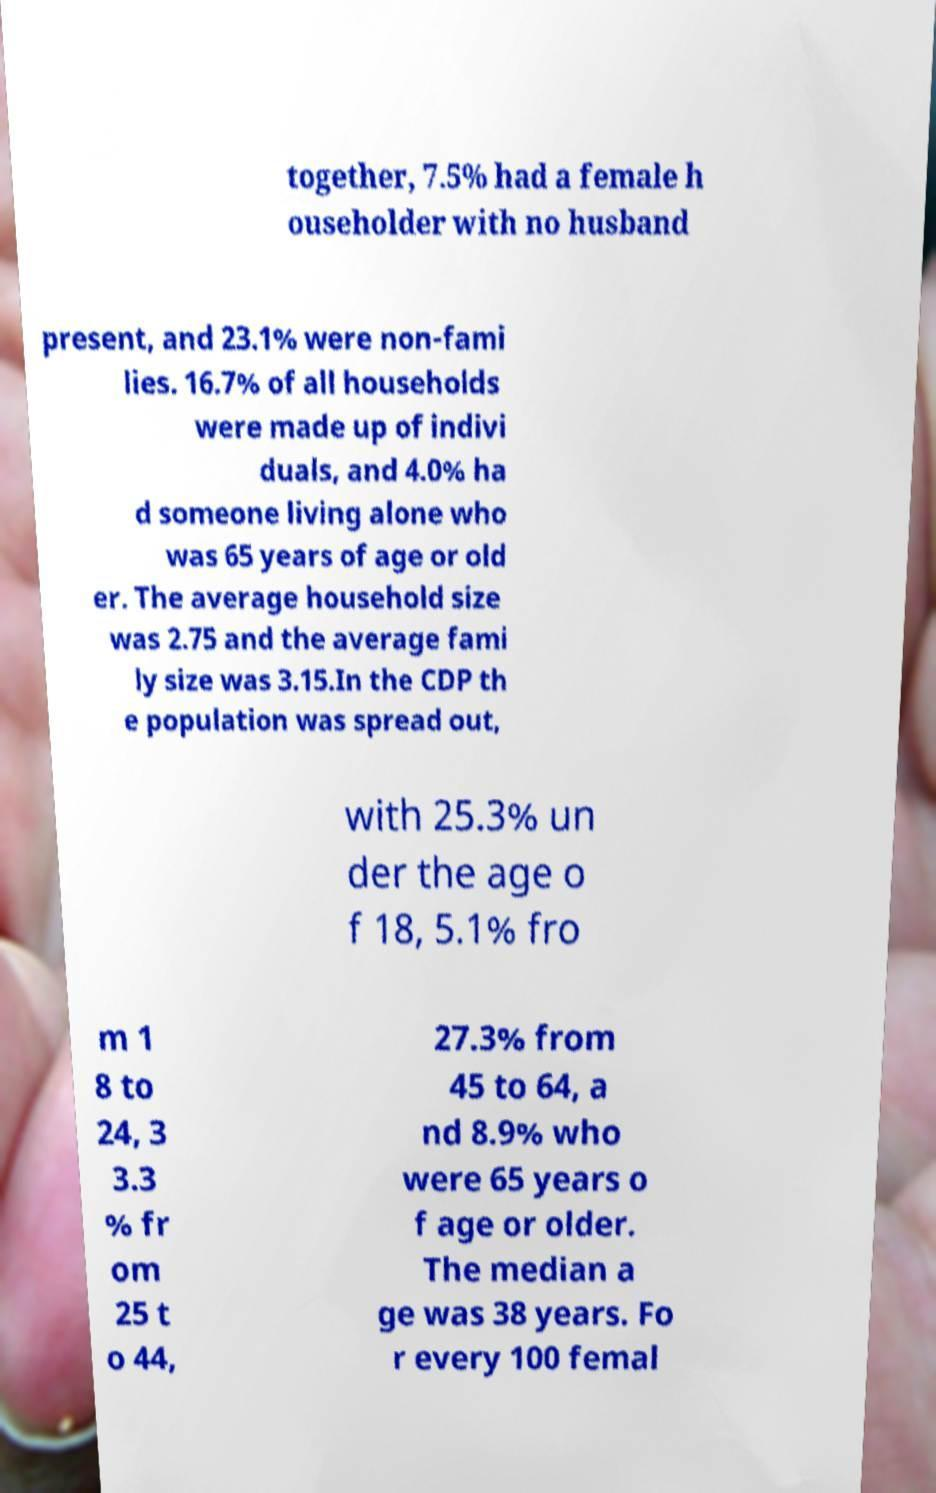Could you assist in decoding the text presented in this image and type it out clearly? together, 7.5% had a female h ouseholder with no husband present, and 23.1% were non-fami lies. 16.7% of all households were made up of indivi duals, and 4.0% ha d someone living alone who was 65 years of age or old er. The average household size was 2.75 and the average fami ly size was 3.15.In the CDP th e population was spread out, with 25.3% un der the age o f 18, 5.1% fro m 1 8 to 24, 3 3.3 % fr om 25 t o 44, 27.3% from 45 to 64, a nd 8.9% who were 65 years o f age or older. The median a ge was 38 years. Fo r every 100 femal 